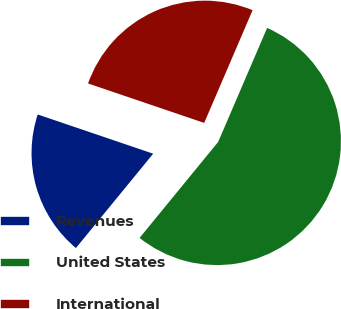Convert chart. <chart><loc_0><loc_0><loc_500><loc_500><pie_chart><fcel>Revenues<fcel>United States<fcel>International<nl><fcel>19.29%<fcel>54.46%<fcel>26.24%<nl></chart> 